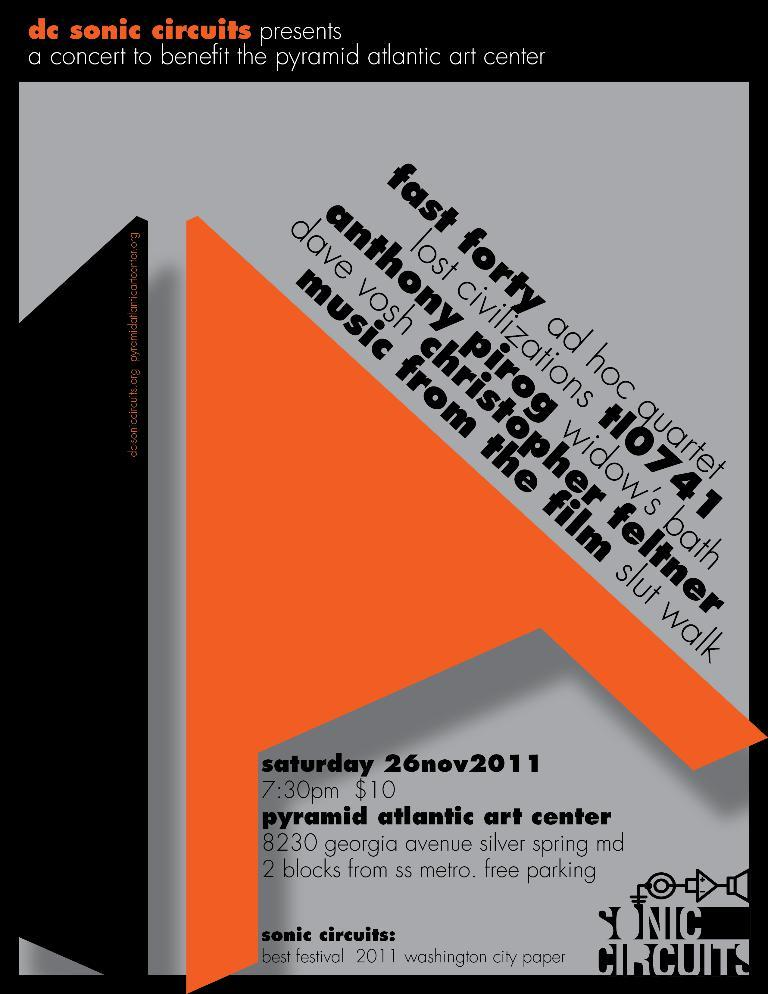Provide a one-sentence caption for the provided image. Poster for a concert that takes place at 7:30 for $10. 